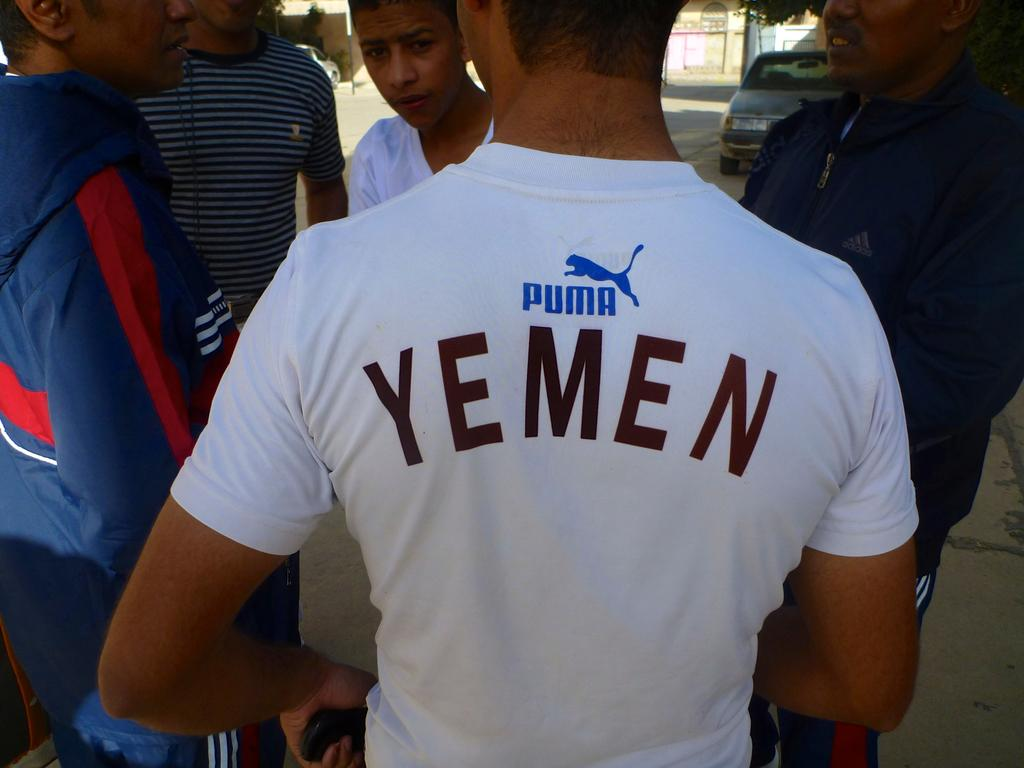Provide a one-sentence caption for the provided image. The young man's white t-shirt proudly displayed, "Yemen". 